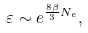Convert formula to latex. <formula><loc_0><loc_0><loc_500><loc_500>\varepsilon \sim e ^ { \frac { 8 \beta } { 3 } N _ { e } } ,</formula> 